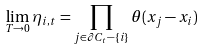<formula> <loc_0><loc_0><loc_500><loc_500>\lim _ { T \rightarrow 0 } \eta _ { i , t } = \prod _ { j \in \partial C _ { t } - \{ i \} } \theta ( x _ { j } - x _ { i } )</formula> 